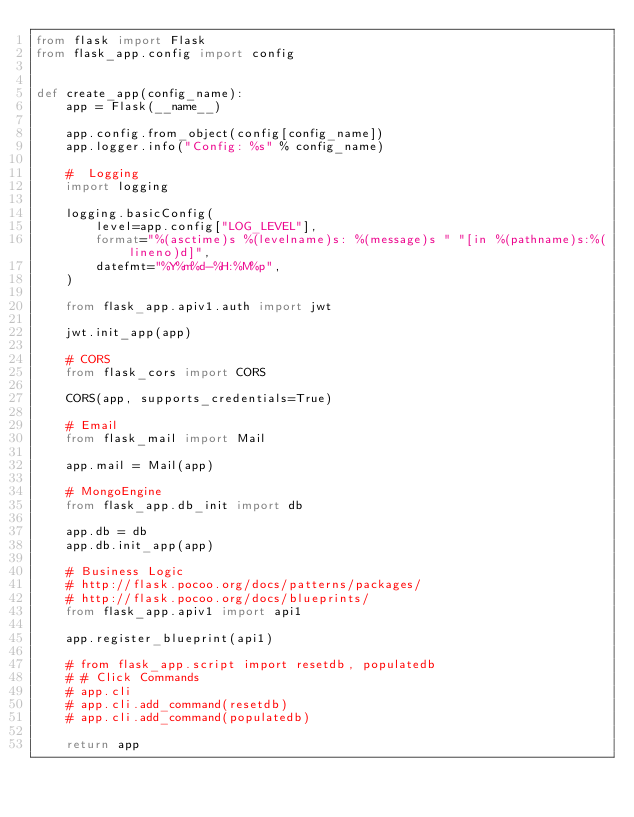Convert code to text. <code><loc_0><loc_0><loc_500><loc_500><_Python_>from flask import Flask
from flask_app.config import config


def create_app(config_name):
    app = Flask(__name__)

    app.config.from_object(config[config_name])
    app.logger.info("Config: %s" % config_name)

    #  Logging
    import logging

    logging.basicConfig(
        level=app.config["LOG_LEVEL"],
        format="%(asctime)s %(levelname)s: %(message)s " "[in %(pathname)s:%(lineno)d]",
        datefmt="%Y%m%d-%H:%M%p",
    )

    from flask_app.apiv1.auth import jwt

    jwt.init_app(app)

    # CORS
    from flask_cors import CORS

    CORS(app, supports_credentials=True)

    # Email
    from flask_mail import Mail

    app.mail = Mail(app)

    # MongoEngine
    from flask_app.db_init import db

    app.db = db
    app.db.init_app(app)

    # Business Logic
    # http://flask.pocoo.org/docs/patterns/packages/
    # http://flask.pocoo.org/docs/blueprints/
    from flask_app.apiv1 import api1

    app.register_blueprint(api1)

    # from flask_app.script import resetdb, populatedb
    # # Click Commands
    # app.cli
    # app.cli.add_command(resetdb)
    # app.cli.add_command(populatedb)

    return app
</code> 